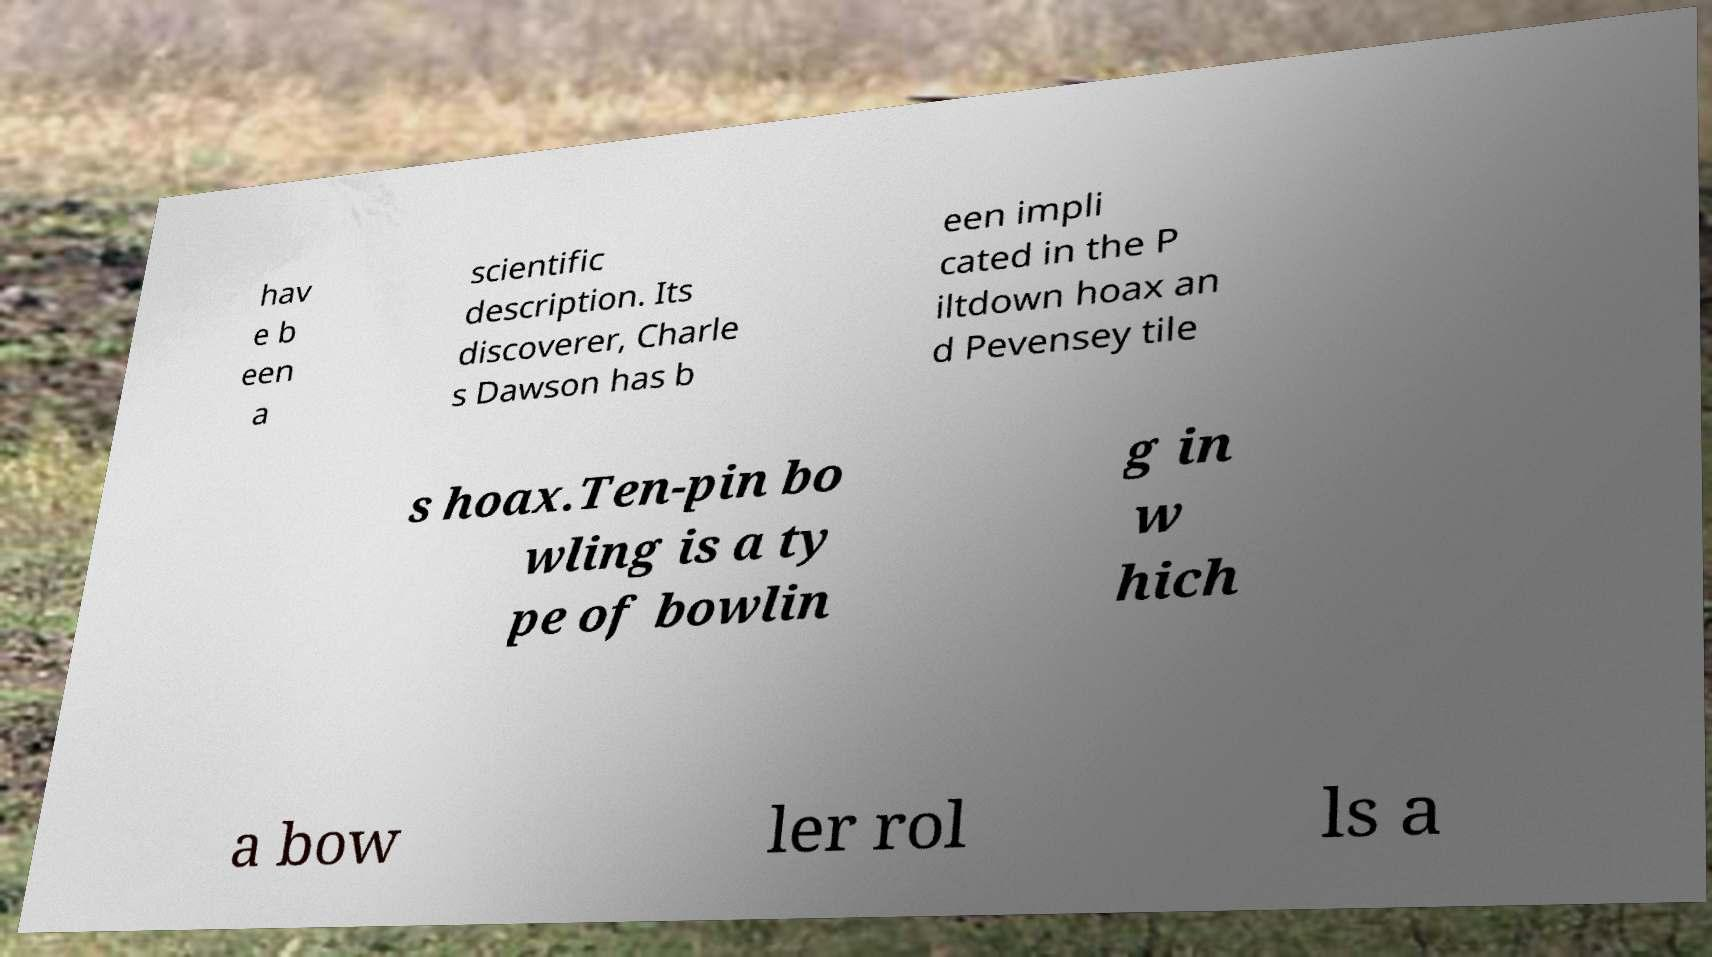Could you extract and type out the text from this image? hav e b een a scientific description. Its discoverer, Charle s Dawson has b een impli cated in the P iltdown hoax an d Pevensey tile s hoax.Ten-pin bo wling is a ty pe of bowlin g in w hich a bow ler rol ls a 